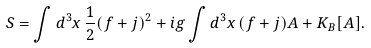Convert formula to latex. <formula><loc_0><loc_0><loc_500><loc_500>S = \int d ^ { 3 } x \, \frac { 1 } { 2 } ( f + j ) ^ { 2 } + i g \int d ^ { 3 } x \, ( f + j ) A + K _ { B } [ A ] .</formula> 